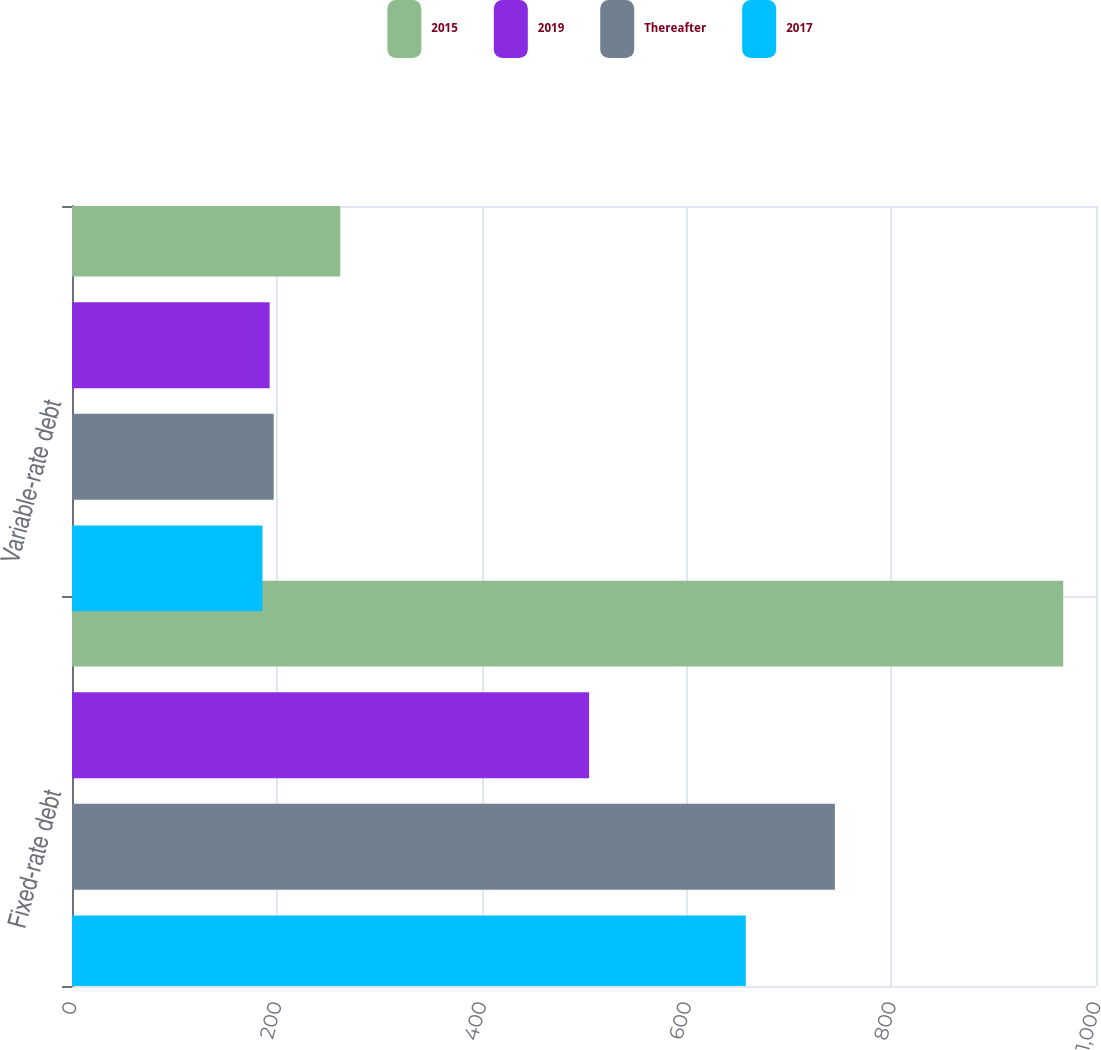<chart> <loc_0><loc_0><loc_500><loc_500><stacked_bar_chart><ecel><fcel>Fixed-rate debt<fcel>Variable-rate debt<nl><fcel>2015<fcel>968<fcel>262<nl><fcel>2019<fcel>505<fcel>193<nl><fcel>Thereafter<fcel>745<fcel>197<nl><fcel>2017<fcel>658<fcel>186<nl></chart> 